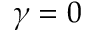Convert formula to latex. <formula><loc_0><loc_0><loc_500><loc_500>\gamma = 0</formula> 